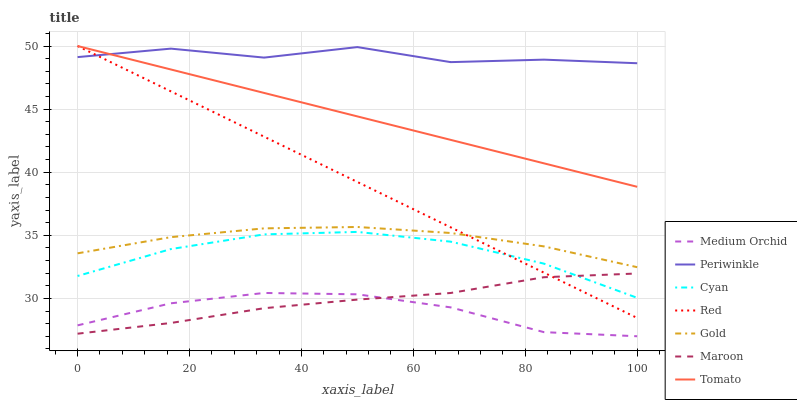Does Medium Orchid have the minimum area under the curve?
Answer yes or no. Yes. Does Periwinkle have the maximum area under the curve?
Answer yes or no. Yes. Does Gold have the minimum area under the curve?
Answer yes or no. No. Does Gold have the maximum area under the curve?
Answer yes or no. No. Is Red the smoothest?
Answer yes or no. Yes. Is Periwinkle the roughest?
Answer yes or no. Yes. Is Gold the smoothest?
Answer yes or no. No. Is Gold the roughest?
Answer yes or no. No. Does Gold have the lowest value?
Answer yes or no. No. Does Gold have the highest value?
Answer yes or no. No. Is Medium Orchid less than Cyan?
Answer yes or no. Yes. Is Periwinkle greater than Gold?
Answer yes or no. Yes. Does Medium Orchid intersect Cyan?
Answer yes or no. No. 